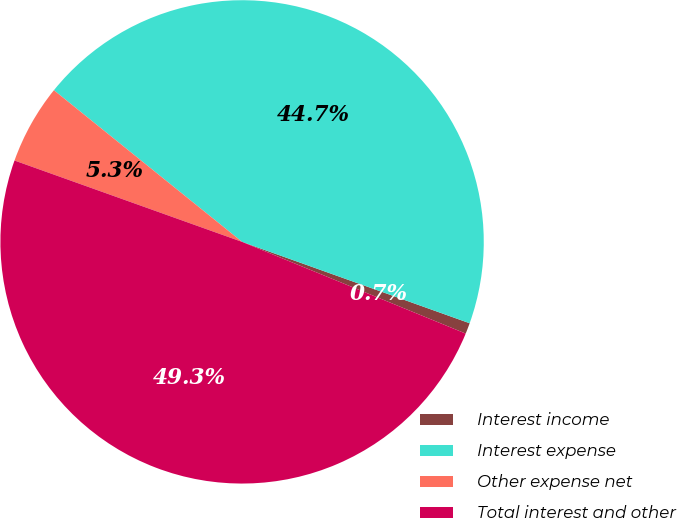Convert chart. <chart><loc_0><loc_0><loc_500><loc_500><pie_chart><fcel>Interest income<fcel>Interest expense<fcel>Other expense net<fcel>Total interest and other<nl><fcel>0.73%<fcel>44.67%<fcel>5.33%<fcel>49.27%<nl></chart> 